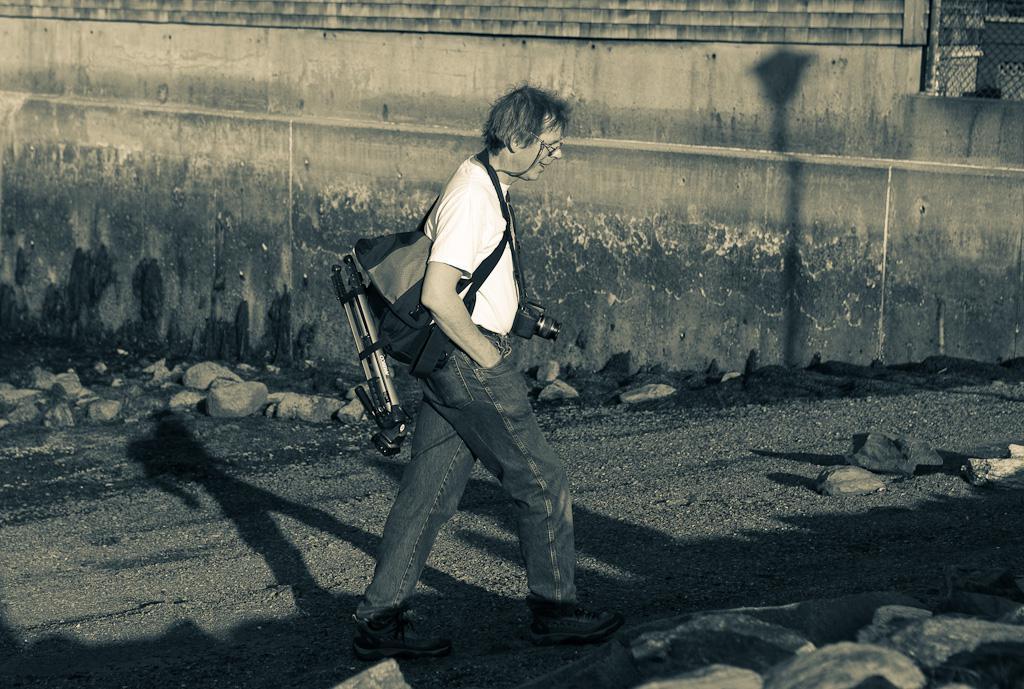Can you describe this image briefly? In this black and white image there is a person walking on the path and he is holding a bag and a camera. On the either sides of the path there are rocks. In the background there is a building. 